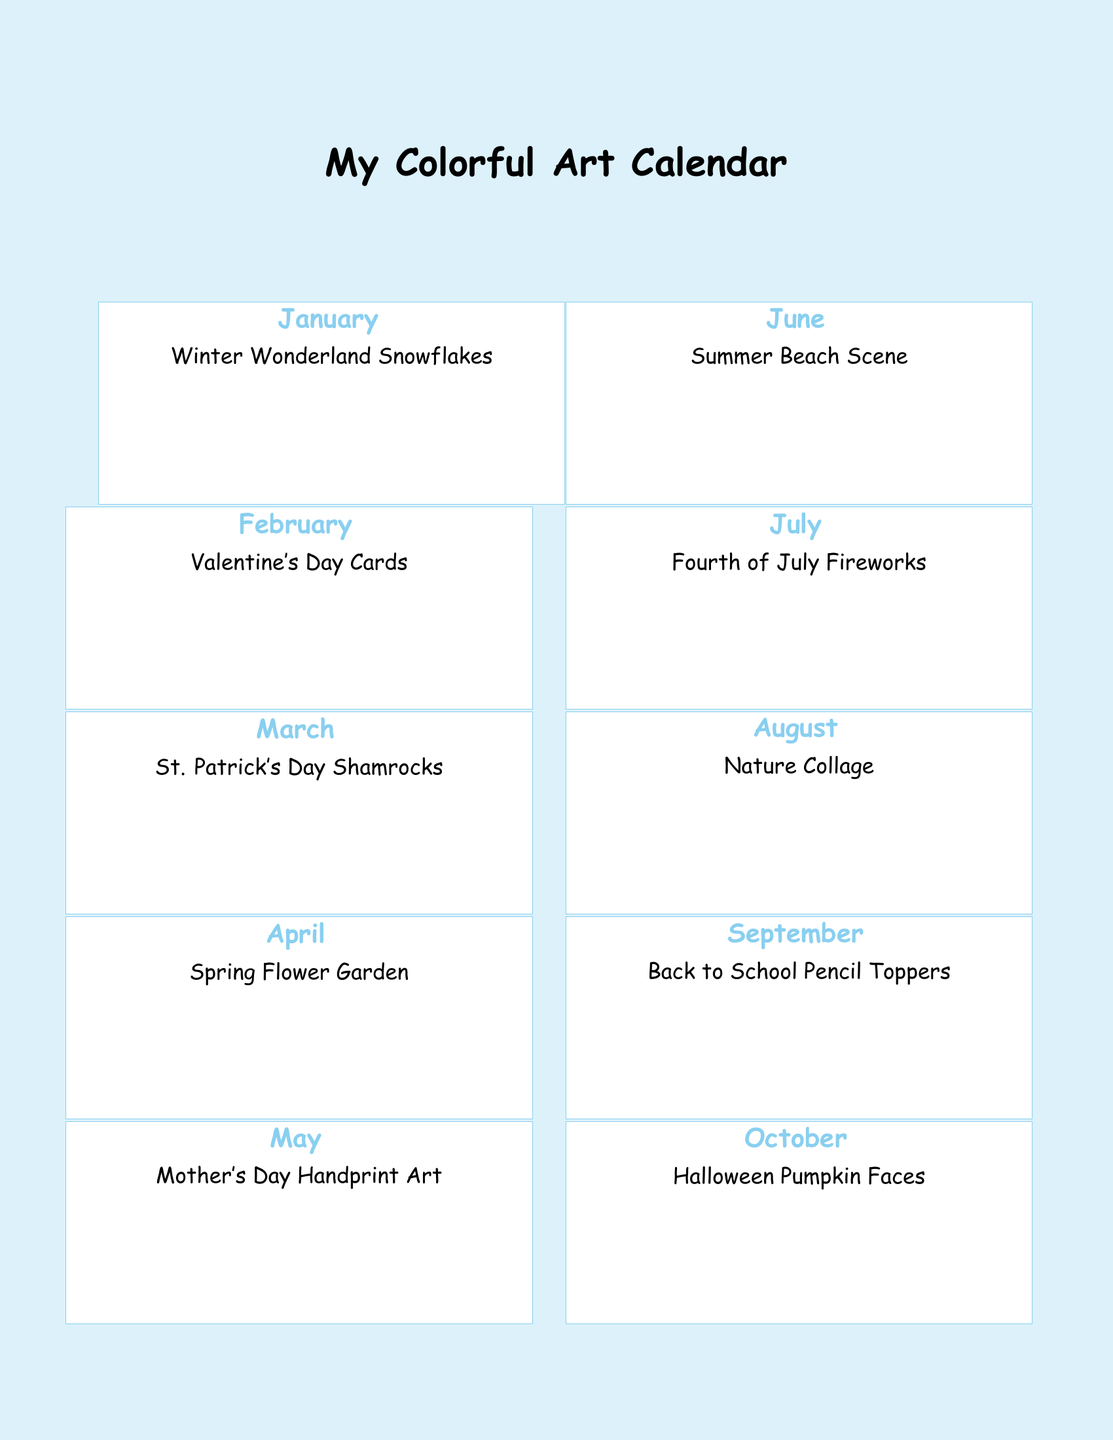What month features snowflakes? The document lists January as the month with a theme of Winter Wonderland Snowflakes.
Answer: January What is the special craft day on March 17? The document specifies Shamrock Craft Day as the special event for St. Patrick's Day on March 17.
Answer: Shamrock Craft Day Which month has a flower garden theme? The document indicates that April is dedicated to Spring Flower Garden activities.
Answer: April How many special craft days are highlighted in the calendar? The document lists six special craft days in total throughout the calendar.
Answer: Six What activity is planned for December 25? According to the document, the activity planned for December 25 is Ornament Making.
Answer: Ornament Making Which month features a beach scene? The calendar specifies June for the theme of Summer Beach Scene.
Answer: June What is the date of Valentine's Day? The document indicates that Valentine's Day is on February 14.
Answer: February 14 What unique craft activity is suggested for Mother's Day? The document lists Handprint Art Creation as the craft activity for Mother's Day on May 8.
Answer: Handprint Art Creation What is the title of the document? The document's title is My Colorful Art Calendar.
Answer: My Colorful Art Calendar 